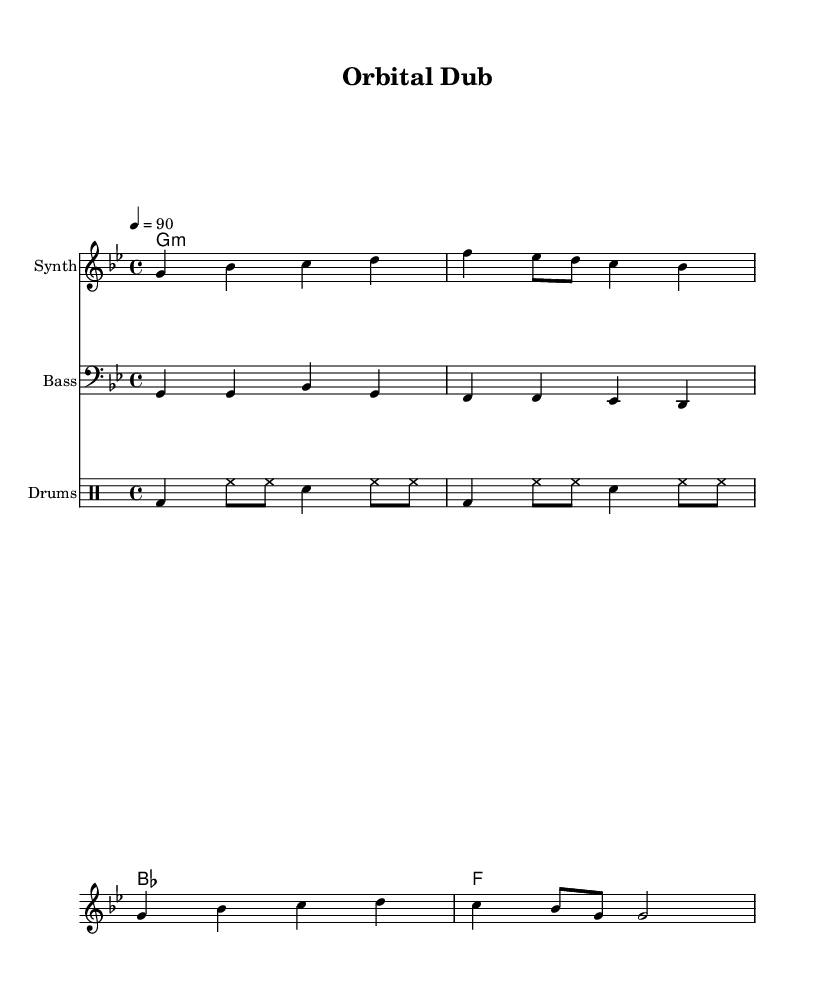What is the title of this piece? The title is found at the top of the sheet music under the header section, which clearly lists "Orbital Dub".
Answer: Orbital Dub What is the key signature of this music? The key signature is G minor, which is indicated by the presence of 'B flat' in the key signature placed at the beginning of the staff.
Answer: G minor What is the time signature of this piece? The time signature is displayed next to the key signature and it is written as 4/4, meaning there are four beats per measure and each quarter note gets one beat.
Answer: 4/4 What is the tempo marking in this music? The tempo is noted in beats per minute, which is represented by '4 = 90' indicating that the quarter note gets 90 beats per minute.
Answer: 90 How many measures are in the melody? Counting the segments separated by vertical bars in the melody line indicates there are four measures as each segment represents one measure.
Answer: 4 What is the primary instrument for this piece? The instrument is indicated in the staff label where it states "Synth", which shows that the melody part is meant to be played on a synthesizer.
Answer: Synth What style of rhythm does this music incorporate? The use of bass drum (bd), hi-hat (hh), and snare drum (sn) in the drum part suggests a 'one drop' rhythm typical of reggae music, characterized by a laid-back feel.
Answer: One drop 